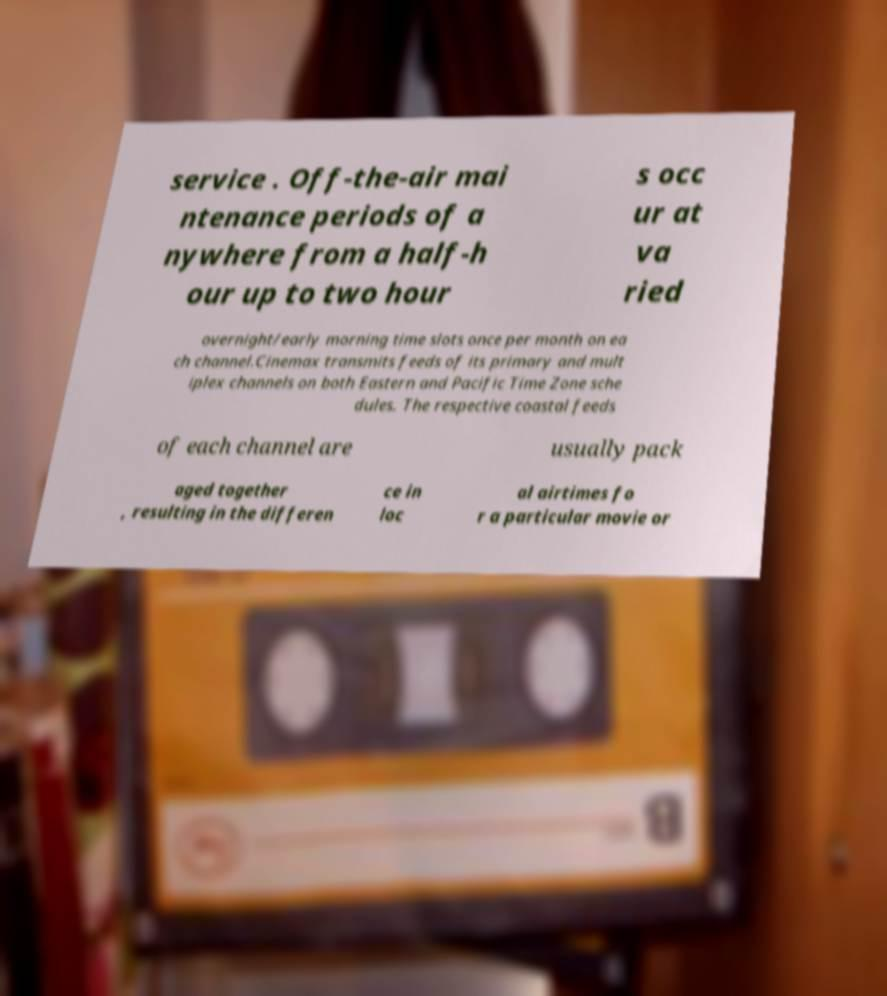Could you assist in decoding the text presented in this image and type it out clearly? service . Off-the-air mai ntenance periods of a nywhere from a half-h our up to two hour s occ ur at va ried overnight/early morning time slots once per month on ea ch channel.Cinemax transmits feeds of its primary and mult iplex channels on both Eastern and Pacific Time Zone sche dules. The respective coastal feeds of each channel are usually pack aged together , resulting in the differen ce in loc al airtimes fo r a particular movie or 